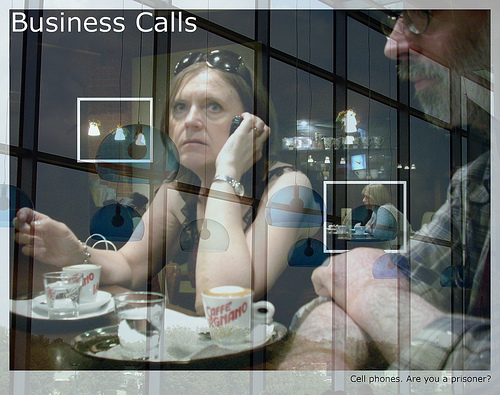Are there rackets in the image? No, there are no rackets visible in the image. 